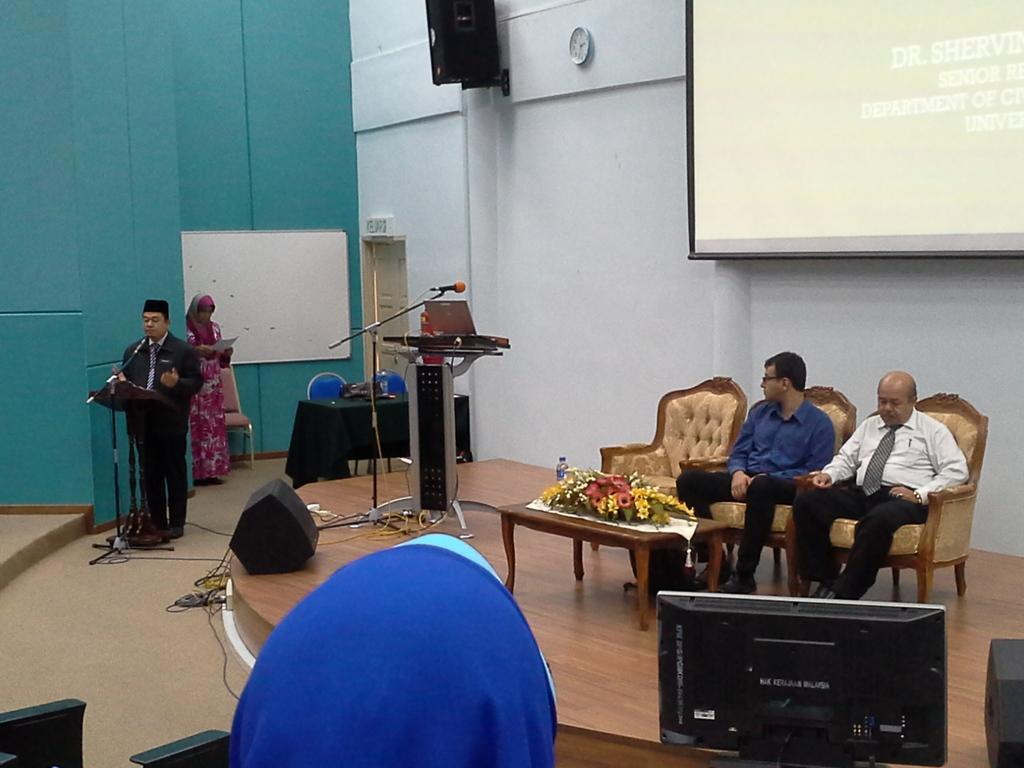Please provide a concise description of this image. This picture describes about group of people few are seated on the chair and few are standing in front of the seated people we can find a bottle and flowers on the table, and a person is standing he is speaking with the help of microphone, in the background we can see a notice board, wall, speaker, clock and a projector screen. 